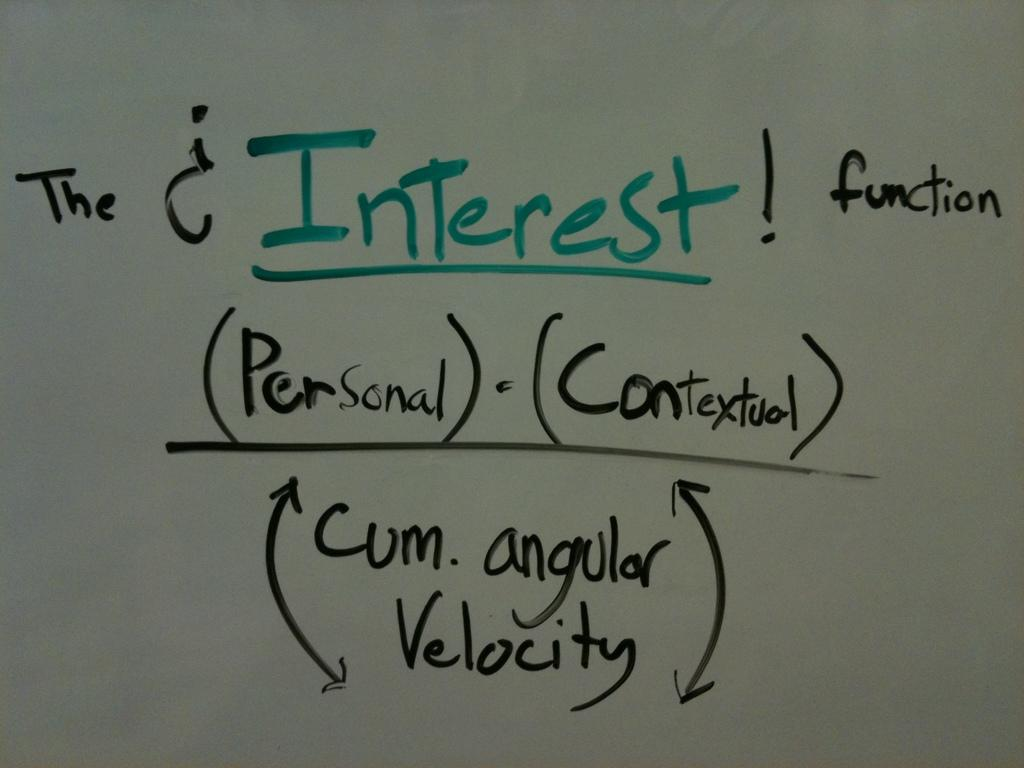<image>
Summarize the visual content of the image. a white board reads The Interest Function in two colors of ink 